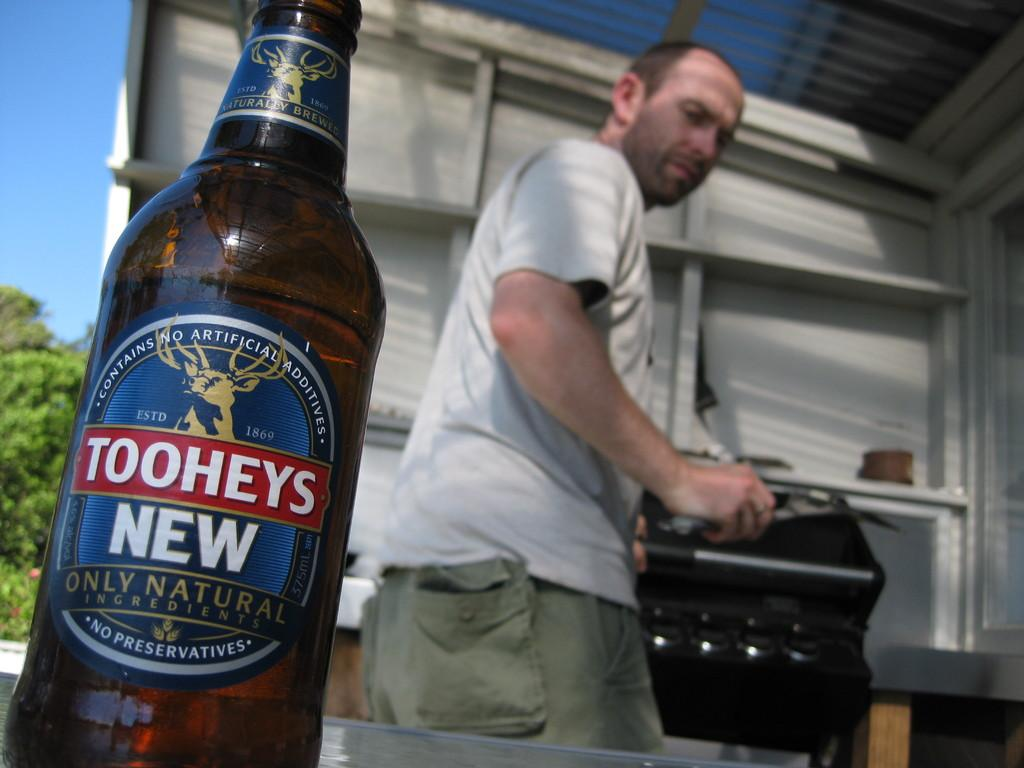<image>
Offer a succinct explanation of the picture presented. a Toohey's New beer bottle in front of a man grilling outdoors 